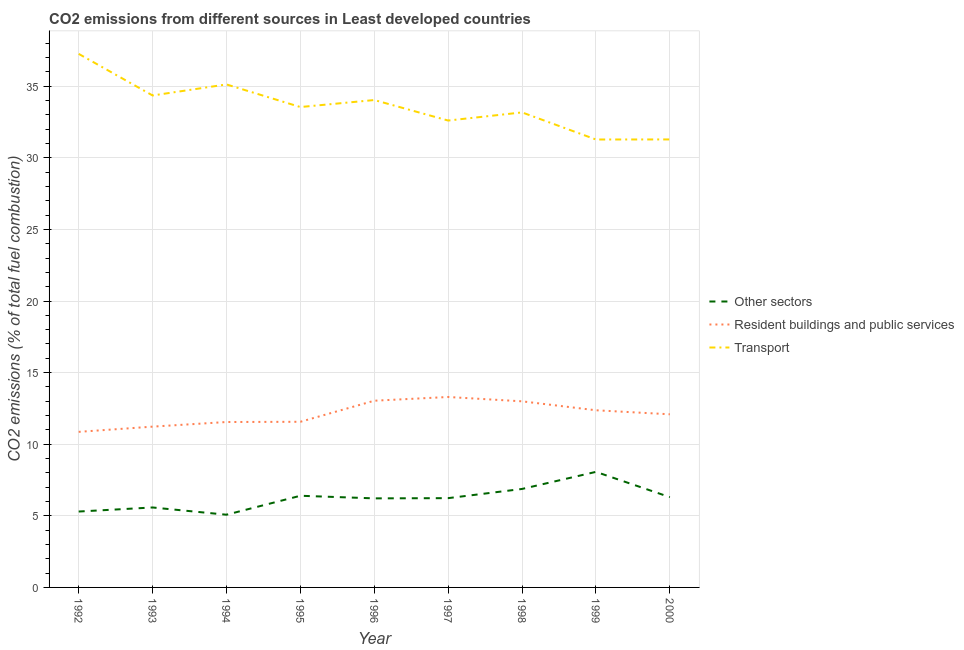How many different coloured lines are there?
Make the answer very short. 3. Does the line corresponding to percentage of co2 emissions from transport intersect with the line corresponding to percentage of co2 emissions from other sectors?
Offer a very short reply. No. What is the percentage of co2 emissions from other sectors in 1999?
Your answer should be compact. 8.07. Across all years, what is the maximum percentage of co2 emissions from resident buildings and public services?
Your answer should be compact. 13.3. Across all years, what is the minimum percentage of co2 emissions from resident buildings and public services?
Offer a terse response. 10.86. In which year was the percentage of co2 emissions from other sectors maximum?
Provide a succinct answer. 1999. What is the total percentage of co2 emissions from transport in the graph?
Provide a succinct answer. 302.67. What is the difference between the percentage of co2 emissions from transport in 1993 and that in 1996?
Your response must be concise. 0.32. What is the difference between the percentage of co2 emissions from transport in 1996 and the percentage of co2 emissions from resident buildings and public services in 1993?
Offer a terse response. 22.81. What is the average percentage of co2 emissions from other sectors per year?
Your response must be concise. 6.23. In the year 1999, what is the difference between the percentage of co2 emissions from transport and percentage of co2 emissions from other sectors?
Keep it short and to the point. 23.21. What is the ratio of the percentage of co2 emissions from resident buildings and public services in 1998 to that in 2000?
Offer a terse response. 1.07. What is the difference between the highest and the second highest percentage of co2 emissions from other sectors?
Give a very brief answer. 1.19. What is the difference between the highest and the lowest percentage of co2 emissions from resident buildings and public services?
Ensure brevity in your answer.  2.43. How many lines are there?
Give a very brief answer. 3. Are the values on the major ticks of Y-axis written in scientific E-notation?
Offer a very short reply. No. Where does the legend appear in the graph?
Provide a succinct answer. Center right. How many legend labels are there?
Offer a very short reply. 3. How are the legend labels stacked?
Provide a short and direct response. Vertical. What is the title of the graph?
Keep it short and to the point. CO2 emissions from different sources in Least developed countries. What is the label or title of the Y-axis?
Provide a succinct answer. CO2 emissions (% of total fuel combustion). What is the CO2 emissions (% of total fuel combustion) in Other sectors in 1992?
Ensure brevity in your answer.  5.3. What is the CO2 emissions (% of total fuel combustion) in Resident buildings and public services in 1992?
Your answer should be compact. 10.86. What is the CO2 emissions (% of total fuel combustion) in Transport in 1992?
Your response must be concise. 37.26. What is the CO2 emissions (% of total fuel combustion) of Other sectors in 1993?
Keep it short and to the point. 5.58. What is the CO2 emissions (% of total fuel combustion) in Resident buildings and public services in 1993?
Your response must be concise. 11.23. What is the CO2 emissions (% of total fuel combustion) in Transport in 1993?
Ensure brevity in your answer.  34.36. What is the CO2 emissions (% of total fuel combustion) in Other sectors in 1994?
Offer a terse response. 5.08. What is the CO2 emissions (% of total fuel combustion) of Resident buildings and public services in 1994?
Provide a short and direct response. 11.55. What is the CO2 emissions (% of total fuel combustion) in Transport in 1994?
Provide a short and direct response. 35.13. What is the CO2 emissions (% of total fuel combustion) of Other sectors in 1995?
Give a very brief answer. 6.4. What is the CO2 emissions (% of total fuel combustion) of Resident buildings and public services in 1995?
Offer a very short reply. 11.57. What is the CO2 emissions (% of total fuel combustion) in Transport in 1995?
Keep it short and to the point. 33.55. What is the CO2 emissions (% of total fuel combustion) of Other sectors in 1996?
Your response must be concise. 6.22. What is the CO2 emissions (% of total fuel combustion) of Resident buildings and public services in 1996?
Ensure brevity in your answer.  13.04. What is the CO2 emissions (% of total fuel combustion) in Transport in 1996?
Keep it short and to the point. 34.04. What is the CO2 emissions (% of total fuel combustion) of Other sectors in 1997?
Ensure brevity in your answer.  6.23. What is the CO2 emissions (% of total fuel combustion) in Resident buildings and public services in 1997?
Give a very brief answer. 13.3. What is the CO2 emissions (% of total fuel combustion) of Transport in 1997?
Provide a short and direct response. 32.6. What is the CO2 emissions (% of total fuel combustion) of Other sectors in 1998?
Give a very brief answer. 6.88. What is the CO2 emissions (% of total fuel combustion) in Resident buildings and public services in 1998?
Provide a short and direct response. 13. What is the CO2 emissions (% of total fuel combustion) of Transport in 1998?
Your answer should be very brief. 33.17. What is the CO2 emissions (% of total fuel combustion) in Other sectors in 1999?
Keep it short and to the point. 8.07. What is the CO2 emissions (% of total fuel combustion) in Resident buildings and public services in 1999?
Your answer should be compact. 12.37. What is the CO2 emissions (% of total fuel combustion) in Transport in 1999?
Give a very brief answer. 31.28. What is the CO2 emissions (% of total fuel combustion) in Other sectors in 2000?
Provide a succinct answer. 6.3. What is the CO2 emissions (% of total fuel combustion) of Resident buildings and public services in 2000?
Offer a very short reply. 12.09. What is the CO2 emissions (% of total fuel combustion) of Transport in 2000?
Offer a terse response. 31.29. Across all years, what is the maximum CO2 emissions (% of total fuel combustion) of Other sectors?
Make the answer very short. 8.07. Across all years, what is the maximum CO2 emissions (% of total fuel combustion) in Resident buildings and public services?
Keep it short and to the point. 13.3. Across all years, what is the maximum CO2 emissions (% of total fuel combustion) in Transport?
Give a very brief answer. 37.26. Across all years, what is the minimum CO2 emissions (% of total fuel combustion) of Other sectors?
Your response must be concise. 5.08. Across all years, what is the minimum CO2 emissions (% of total fuel combustion) in Resident buildings and public services?
Provide a succinct answer. 10.86. Across all years, what is the minimum CO2 emissions (% of total fuel combustion) of Transport?
Keep it short and to the point. 31.28. What is the total CO2 emissions (% of total fuel combustion) in Other sectors in the graph?
Offer a terse response. 56.07. What is the total CO2 emissions (% of total fuel combustion) of Resident buildings and public services in the graph?
Provide a succinct answer. 109.01. What is the total CO2 emissions (% of total fuel combustion) in Transport in the graph?
Ensure brevity in your answer.  302.67. What is the difference between the CO2 emissions (% of total fuel combustion) in Other sectors in 1992 and that in 1993?
Your answer should be very brief. -0.28. What is the difference between the CO2 emissions (% of total fuel combustion) of Resident buildings and public services in 1992 and that in 1993?
Ensure brevity in your answer.  -0.36. What is the difference between the CO2 emissions (% of total fuel combustion) in Transport in 1992 and that in 1993?
Your response must be concise. 2.91. What is the difference between the CO2 emissions (% of total fuel combustion) in Other sectors in 1992 and that in 1994?
Keep it short and to the point. 0.22. What is the difference between the CO2 emissions (% of total fuel combustion) of Resident buildings and public services in 1992 and that in 1994?
Give a very brief answer. -0.69. What is the difference between the CO2 emissions (% of total fuel combustion) of Transport in 1992 and that in 1994?
Offer a very short reply. 2.13. What is the difference between the CO2 emissions (% of total fuel combustion) in Other sectors in 1992 and that in 1995?
Offer a terse response. -1.1. What is the difference between the CO2 emissions (% of total fuel combustion) in Resident buildings and public services in 1992 and that in 1995?
Your answer should be compact. -0.7. What is the difference between the CO2 emissions (% of total fuel combustion) of Transport in 1992 and that in 1995?
Your response must be concise. 3.71. What is the difference between the CO2 emissions (% of total fuel combustion) of Other sectors in 1992 and that in 1996?
Your response must be concise. -0.92. What is the difference between the CO2 emissions (% of total fuel combustion) in Resident buildings and public services in 1992 and that in 1996?
Provide a succinct answer. -2.17. What is the difference between the CO2 emissions (% of total fuel combustion) of Transport in 1992 and that in 1996?
Give a very brief answer. 3.22. What is the difference between the CO2 emissions (% of total fuel combustion) in Other sectors in 1992 and that in 1997?
Keep it short and to the point. -0.94. What is the difference between the CO2 emissions (% of total fuel combustion) in Resident buildings and public services in 1992 and that in 1997?
Keep it short and to the point. -2.43. What is the difference between the CO2 emissions (% of total fuel combustion) in Transport in 1992 and that in 1997?
Your answer should be compact. 4.66. What is the difference between the CO2 emissions (% of total fuel combustion) in Other sectors in 1992 and that in 1998?
Provide a short and direct response. -1.58. What is the difference between the CO2 emissions (% of total fuel combustion) of Resident buildings and public services in 1992 and that in 1998?
Offer a terse response. -2.13. What is the difference between the CO2 emissions (% of total fuel combustion) in Transport in 1992 and that in 1998?
Offer a terse response. 4.09. What is the difference between the CO2 emissions (% of total fuel combustion) in Other sectors in 1992 and that in 1999?
Provide a short and direct response. -2.77. What is the difference between the CO2 emissions (% of total fuel combustion) in Resident buildings and public services in 1992 and that in 1999?
Provide a short and direct response. -1.51. What is the difference between the CO2 emissions (% of total fuel combustion) in Transport in 1992 and that in 1999?
Provide a short and direct response. 5.98. What is the difference between the CO2 emissions (% of total fuel combustion) of Other sectors in 1992 and that in 2000?
Give a very brief answer. -1. What is the difference between the CO2 emissions (% of total fuel combustion) in Resident buildings and public services in 1992 and that in 2000?
Your response must be concise. -1.23. What is the difference between the CO2 emissions (% of total fuel combustion) in Transport in 1992 and that in 2000?
Make the answer very short. 5.98. What is the difference between the CO2 emissions (% of total fuel combustion) in Other sectors in 1993 and that in 1994?
Your response must be concise. 0.51. What is the difference between the CO2 emissions (% of total fuel combustion) in Resident buildings and public services in 1993 and that in 1994?
Make the answer very short. -0.32. What is the difference between the CO2 emissions (% of total fuel combustion) of Transport in 1993 and that in 1994?
Provide a succinct answer. -0.77. What is the difference between the CO2 emissions (% of total fuel combustion) in Other sectors in 1993 and that in 1995?
Your answer should be compact. -0.82. What is the difference between the CO2 emissions (% of total fuel combustion) in Resident buildings and public services in 1993 and that in 1995?
Give a very brief answer. -0.34. What is the difference between the CO2 emissions (% of total fuel combustion) in Transport in 1993 and that in 1995?
Your response must be concise. 0.81. What is the difference between the CO2 emissions (% of total fuel combustion) of Other sectors in 1993 and that in 1996?
Offer a terse response. -0.64. What is the difference between the CO2 emissions (% of total fuel combustion) in Resident buildings and public services in 1993 and that in 1996?
Ensure brevity in your answer.  -1.81. What is the difference between the CO2 emissions (% of total fuel combustion) of Transport in 1993 and that in 1996?
Provide a short and direct response. 0.32. What is the difference between the CO2 emissions (% of total fuel combustion) in Other sectors in 1993 and that in 1997?
Offer a terse response. -0.65. What is the difference between the CO2 emissions (% of total fuel combustion) in Resident buildings and public services in 1993 and that in 1997?
Offer a very short reply. -2.07. What is the difference between the CO2 emissions (% of total fuel combustion) in Transport in 1993 and that in 1997?
Ensure brevity in your answer.  1.75. What is the difference between the CO2 emissions (% of total fuel combustion) in Other sectors in 1993 and that in 1998?
Offer a very short reply. -1.29. What is the difference between the CO2 emissions (% of total fuel combustion) in Resident buildings and public services in 1993 and that in 1998?
Give a very brief answer. -1.77. What is the difference between the CO2 emissions (% of total fuel combustion) of Transport in 1993 and that in 1998?
Provide a short and direct response. 1.18. What is the difference between the CO2 emissions (% of total fuel combustion) of Other sectors in 1993 and that in 1999?
Make the answer very short. -2.49. What is the difference between the CO2 emissions (% of total fuel combustion) of Resident buildings and public services in 1993 and that in 1999?
Offer a very short reply. -1.14. What is the difference between the CO2 emissions (% of total fuel combustion) in Transport in 1993 and that in 1999?
Offer a terse response. 3.08. What is the difference between the CO2 emissions (% of total fuel combustion) of Other sectors in 1993 and that in 2000?
Your response must be concise. -0.72. What is the difference between the CO2 emissions (% of total fuel combustion) in Resident buildings and public services in 1993 and that in 2000?
Keep it short and to the point. -0.86. What is the difference between the CO2 emissions (% of total fuel combustion) of Transport in 1993 and that in 2000?
Your response must be concise. 3.07. What is the difference between the CO2 emissions (% of total fuel combustion) of Other sectors in 1994 and that in 1995?
Offer a terse response. -1.32. What is the difference between the CO2 emissions (% of total fuel combustion) in Resident buildings and public services in 1994 and that in 1995?
Keep it short and to the point. -0.02. What is the difference between the CO2 emissions (% of total fuel combustion) of Transport in 1994 and that in 1995?
Your response must be concise. 1.58. What is the difference between the CO2 emissions (% of total fuel combustion) in Other sectors in 1994 and that in 1996?
Provide a short and direct response. -1.14. What is the difference between the CO2 emissions (% of total fuel combustion) of Resident buildings and public services in 1994 and that in 1996?
Provide a short and direct response. -1.49. What is the difference between the CO2 emissions (% of total fuel combustion) in Transport in 1994 and that in 1996?
Your answer should be compact. 1.09. What is the difference between the CO2 emissions (% of total fuel combustion) of Other sectors in 1994 and that in 1997?
Provide a short and direct response. -1.16. What is the difference between the CO2 emissions (% of total fuel combustion) of Resident buildings and public services in 1994 and that in 1997?
Provide a succinct answer. -1.75. What is the difference between the CO2 emissions (% of total fuel combustion) of Transport in 1994 and that in 1997?
Your response must be concise. 2.52. What is the difference between the CO2 emissions (% of total fuel combustion) of Other sectors in 1994 and that in 1998?
Make the answer very short. -1.8. What is the difference between the CO2 emissions (% of total fuel combustion) of Resident buildings and public services in 1994 and that in 1998?
Ensure brevity in your answer.  -1.44. What is the difference between the CO2 emissions (% of total fuel combustion) of Transport in 1994 and that in 1998?
Keep it short and to the point. 1.95. What is the difference between the CO2 emissions (% of total fuel combustion) of Other sectors in 1994 and that in 1999?
Your response must be concise. -2.99. What is the difference between the CO2 emissions (% of total fuel combustion) in Resident buildings and public services in 1994 and that in 1999?
Your response must be concise. -0.82. What is the difference between the CO2 emissions (% of total fuel combustion) in Transport in 1994 and that in 1999?
Keep it short and to the point. 3.85. What is the difference between the CO2 emissions (% of total fuel combustion) of Other sectors in 1994 and that in 2000?
Provide a short and direct response. -1.23. What is the difference between the CO2 emissions (% of total fuel combustion) of Resident buildings and public services in 1994 and that in 2000?
Ensure brevity in your answer.  -0.54. What is the difference between the CO2 emissions (% of total fuel combustion) in Transport in 1994 and that in 2000?
Offer a very short reply. 3.84. What is the difference between the CO2 emissions (% of total fuel combustion) in Other sectors in 1995 and that in 1996?
Give a very brief answer. 0.18. What is the difference between the CO2 emissions (% of total fuel combustion) of Resident buildings and public services in 1995 and that in 1996?
Give a very brief answer. -1.47. What is the difference between the CO2 emissions (% of total fuel combustion) of Transport in 1995 and that in 1996?
Provide a succinct answer. -0.49. What is the difference between the CO2 emissions (% of total fuel combustion) of Other sectors in 1995 and that in 1997?
Your answer should be very brief. 0.17. What is the difference between the CO2 emissions (% of total fuel combustion) in Resident buildings and public services in 1995 and that in 1997?
Your answer should be compact. -1.73. What is the difference between the CO2 emissions (% of total fuel combustion) of Transport in 1995 and that in 1997?
Offer a very short reply. 0.94. What is the difference between the CO2 emissions (% of total fuel combustion) of Other sectors in 1995 and that in 1998?
Give a very brief answer. -0.48. What is the difference between the CO2 emissions (% of total fuel combustion) in Resident buildings and public services in 1995 and that in 1998?
Your answer should be very brief. -1.43. What is the difference between the CO2 emissions (% of total fuel combustion) of Transport in 1995 and that in 1998?
Provide a succinct answer. 0.37. What is the difference between the CO2 emissions (% of total fuel combustion) of Other sectors in 1995 and that in 1999?
Make the answer very short. -1.67. What is the difference between the CO2 emissions (% of total fuel combustion) in Resident buildings and public services in 1995 and that in 1999?
Offer a terse response. -0.8. What is the difference between the CO2 emissions (% of total fuel combustion) in Transport in 1995 and that in 1999?
Ensure brevity in your answer.  2.27. What is the difference between the CO2 emissions (% of total fuel combustion) in Other sectors in 1995 and that in 2000?
Offer a very short reply. 0.1. What is the difference between the CO2 emissions (% of total fuel combustion) of Resident buildings and public services in 1995 and that in 2000?
Give a very brief answer. -0.52. What is the difference between the CO2 emissions (% of total fuel combustion) of Transport in 1995 and that in 2000?
Keep it short and to the point. 2.26. What is the difference between the CO2 emissions (% of total fuel combustion) of Other sectors in 1996 and that in 1997?
Ensure brevity in your answer.  -0.02. What is the difference between the CO2 emissions (% of total fuel combustion) of Resident buildings and public services in 1996 and that in 1997?
Your answer should be compact. -0.26. What is the difference between the CO2 emissions (% of total fuel combustion) in Transport in 1996 and that in 1997?
Ensure brevity in your answer.  1.43. What is the difference between the CO2 emissions (% of total fuel combustion) in Other sectors in 1996 and that in 1998?
Keep it short and to the point. -0.66. What is the difference between the CO2 emissions (% of total fuel combustion) in Resident buildings and public services in 1996 and that in 1998?
Provide a succinct answer. 0.04. What is the difference between the CO2 emissions (% of total fuel combustion) in Transport in 1996 and that in 1998?
Make the answer very short. 0.86. What is the difference between the CO2 emissions (% of total fuel combustion) of Other sectors in 1996 and that in 1999?
Make the answer very short. -1.85. What is the difference between the CO2 emissions (% of total fuel combustion) in Resident buildings and public services in 1996 and that in 1999?
Keep it short and to the point. 0.67. What is the difference between the CO2 emissions (% of total fuel combustion) in Transport in 1996 and that in 1999?
Your answer should be very brief. 2.76. What is the difference between the CO2 emissions (% of total fuel combustion) of Other sectors in 1996 and that in 2000?
Offer a terse response. -0.08. What is the difference between the CO2 emissions (% of total fuel combustion) of Resident buildings and public services in 1996 and that in 2000?
Your response must be concise. 0.95. What is the difference between the CO2 emissions (% of total fuel combustion) in Transport in 1996 and that in 2000?
Offer a very short reply. 2.75. What is the difference between the CO2 emissions (% of total fuel combustion) in Other sectors in 1997 and that in 1998?
Your answer should be compact. -0.64. What is the difference between the CO2 emissions (% of total fuel combustion) of Resident buildings and public services in 1997 and that in 1998?
Your answer should be very brief. 0.3. What is the difference between the CO2 emissions (% of total fuel combustion) in Transport in 1997 and that in 1998?
Give a very brief answer. -0.57. What is the difference between the CO2 emissions (% of total fuel combustion) in Other sectors in 1997 and that in 1999?
Your answer should be very brief. -1.84. What is the difference between the CO2 emissions (% of total fuel combustion) of Resident buildings and public services in 1997 and that in 1999?
Keep it short and to the point. 0.93. What is the difference between the CO2 emissions (% of total fuel combustion) of Transport in 1997 and that in 1999?
Offer a terse response. 1.32. What is the difference between the CO2 emissions (% of total fuel combustion) of Other sectors in 1997 and that in 2000?
Give a very brief answer. -0.07. What is the difference between the CO2 emissions (% of total fuel combustion) in Resident buildings and public services in 1997 and that in 2000?
Provide a short and direct response. 1.21. What is the difference between the CO2 emissions (% of total fuel combustion) of Transport in 1997 and that in 2000?
Ensure brevity in your answer.  1.32. What is the difference between the CO2 emissions (% of total fuel combustion) of Other sectors in 1998 and that in 1999?
Give a very brief answer. -1.19. What is the difference between the CO2 emissions (% of total fuel combustion) in Resident buildings and public services in 1998 and that in 1999?
Keep it short and to the point. 0.62. What is the difference between the CO2 emissions (% of total fuel combustion) in Transport in 1998 and that in 1999?
Keep it short and to the point. 1.89. What is the difference between the CO2 emissions (% of total fuel combustion) in Other sectors in 1998 and that in 2000?
Give a very brief answer. 0.57. What is the difference between the CO2 emissions (% of total fuel combustion) in Resident buildings and public services in 1998 and that in 2000?
Ensure brevity in your answer.  0.91. What is the difference between the CO2 emissions (% of total fuel combustion) of Transport in 1998 and that in 2000?
Your response must be concise. 1.89. What is the difference between the CO2 emissions (% of total fuel combustion) of Other sectors in 1999 and that in 2000?
Provide a short and direct response. 1.77. What is the difference between the CO2 emissions (% of total fuel combustion) in Resident buildings and public services in 1999 and that in 2000?
Ensure brevity in your answer.  0.28. What is the difference between the CO2 emissions (% of total fuel combustion) in Transport in 1999 and that in 2000?
Offer a very short reply. -0.01. What is the difference between the CO2 emissions (% of total fuel combustion) of Other sectors in 1992 and the CO2 emissions (% of total fuel combustion) of Resident buildings and public services in 1993?
Your response must be concise. -5.93. What is the difference between the CO2 emissions (% of total fuel combustion) of Other sectors in 1992 and the CO2 emissions (% of total fuel combustion) of Transport in 1993?
Ensure brevity in your answer.  -29.06. What is the difference between the CO2 emissions (% of total fuel combustion) in Resident buildings and public services in 1992 and the CO2 emissions (% of total fuel combustion) in Transport in 1993?
Your response must be concise. -23.49. What is the difference between the CO2 emissions (% of total fuel combustion) in Other sectors in 1992 and the CO2 emissions (% of total fuel combustion) in Resident buildings and public services in 1994?
Provide a succinct answer. -6.25. What is the difference between the CO2 emissions (% of total fuel combustion) of Other sectors in 1992 and the CO2 emissions (% of total fuel combustion) of Transport in 1994?
Offer a very short reply. -29.83. What is the difference between the CO2 emissions (% of total fuel combustion) of Resident buildings and public services in 1992 and the CO2 emissions (% of total fuel combustion) of Transport in 1994?
Provide a succinct answer. -24.26. What is the difference between the CO2 emissions (% of total fuel combustion) in Other sectors in 1992 and the CO2 emissions (% of total fuel combustion) in Resident buildings and public services in 1995?
Keep it short and to the point. -6.27. What is the difference between the CO2 emissions (% of total fuel combustion) in Other sectors in 1992 and the CO2 emissions (% of total fuel combustion) in Transport in 1995?
Offer a very short reply. -28.25. What is the difference between the CO2 emissions (% of total fuel combustion) in Resident buildings and public services in 1992 and the CO2 emissions (% of total fuel combustion) in Transport in 1995?
Keep it short and to the point. -22.68. What is the difference between the CO2 emissions (% of total fuel combustion) in Other sectors in 1992 and the CO2 emissions (% of total fuel combustion) in Resident buildings and public services in 1996?
Ensure brevity in your answer.  -7.74. What is the difference between the CO2 emissions (% of total fuel combustion) in Other sectors in 1992 and the CO2 emissions (% of total fuel combustion) in Transport in 1996?
Offer a terse response. -28.74. What is the difference between the CO2 emissions (% of total fuel combustion) of Resident buildings and public services in 1992 and the CO2 emissions (% of total fuel combustion) of Transport in 1996?
Keep it short and to the point. -23.17. What is the difference between the CO2 emissions (% of total fuel combustion) in Other sectors in 1992 and the CO2 emissions (% of total fuel combustion) in Resident buildings and public services in 1997?
Provide a short and direct response. -8. What is the difference between the CO2 emissions (% of total fuel combustion) of Other sectors in 1992 and the CO2 emissions (% of total fuel combustion) of Transport in 1997?
Offer a very short reply. -27.3. What is the difference between the CO2 emissions (% of total fuel combustion) in Resident buildings and public services in 1992 and the CO2 emissions (% of total fuel combustion) in Transport in 1997?
Keep it short and to the point. -21.74. What is the difference between the CO2 emissions (% of total fuel combustion) of Other sectors in 1992 and the CO2 emissions (% of total fuel combustion) of Resident buildings and public services in 1998?
Make the answer very short. -7.7. What is the difference between the CO2 emissions (% of total fuel combustion) of Other sectors in 1992 and the CO2 emissions (% of total fuel combustion) of Transport in 1998?
Provide a succinct answer. -27.87. What is the difference between the CO2 emissions (% of total fuel combustion) in Resident buildings and public services in 1992 and the CO2 emissions (% of total fuel combustion) in Transport in 1998?
Your answer should be compact. -22.31. What is the difference between the CO2 emissions (% of total fuel combustion) in Other sectors in 1992 and the CO2 emissions (% of total fuel combustion) in Resident buildings and public services in 1999?
Your response must be concise. -7.07. What is the difference between the CO2 emissions (% of total fuel combustion) in Other sectors in 1992 and the CO2 emissions (% of total fuel combustion) in Transport in 1999?
Ensure brevity in your answer.  -25.98. What is the difference between the CO2 emissions (% of total fuel combustion) of Resident buildings and public services in 1992 and the CO2 emissions (% of total fuel combustion) of Transport in 1999?
Your response must be concise. -20.42. What is the difference between the CO2 emissions (% of total fuel combustion) in Other sectors in 1992 and the CO2 emissions (% of total fuel combustion) in Resident buildings and public services in 2000?
Your answer should be very brief. -6.79. What is the difference between the CO2 emissions (% of total fuel combustion) of Other sectors in 1992 and the CO2 emissions (% of total fuel combustion) of Transport in 2000?
Your response must be concise. -25.99. What is the difference between the CO2 emissions (% of total fuel combustion) in Resident buildings and public services in 1992 and the CO2 emissions (% of total fuel combustion) in Transport in 2000?
Give a very brief answer. -20.42. What is the difference between the CO2 emissions (% of total fuel combustion) in Other sectors in 1993 and the CO2 emissions (% of total fuel combustion) in Resident buildings and public services in 1994?
Your answer should be compact. -5.97. What is the difference between the CO2 emissions (% of total fuel combustion) in Other sectors in 1993 and the CO2 emissions (% of total fuel combustion) in Transport in 1994?
Keep it short and to the point. -29.54. What is the difference between the CO2 emissions (% of total fuel combustion) in Resident buildings and public services in 1993 and the CO2 emissions (% of total fuel combustion) in Transport in 1994?
Your response must be concise. -23.9. What is the difference between the CO2 emissions (% of total fuel combustion) in Other sectors in 1993 and the CO2 emissions (% of total fuel combustion) in Resident buildings and public services in 1995?
Your answer should be very brief. -5.98. What is the difference between the CO2 emissions (% of total fuel combustion) of Other sectors in 1993 and the CO2 emissions (% of total fuel combustion) of Transport in 1995?
Ensure brevity in your answer.  -27.96. What is the difference between the CO2 emissions (% of total fuel combustion) in Resident buildings and public services in 1993 and the CO2 emissions (% of total fuel combustion) in Transport in 1995?
Give a very brief answer. -22.32. What is the difference between the CO2 emissions (% of total fuel combustion) of Other sectors in 1993 and the CO2 emissions (% of total fuel combustion) of Resident buildings and public services in 1996?
Keep it short and to the point. -7.46. What is the difference between the CO2 emissions (% of total fuel combustion) of Other sectors in 1993 and the CO2 emissions (% of total fuel combustion) of Transport in 1996?
Provide a short and direct response. -28.45. What is the difference between the CO2 emissions (% of total fuel combustion) of Resident buildings and public services in 1993 and the CO2 emissions (% of total fuel combustion) of Transport in 1996?
Offer a terse response. -22.81. What is the difference between the CO2 emissions (% of total fuel combustion) in Other sectors in 1993 and the CO2 emissions (% of total fuel combustion) in Resident buildings and public services in 1997?
Give a very brief answer. -7.72. What is the difference between the CO2 emissions (% of total fuel combustion) of Other sectors in 1993 and the CO2 emissions (% of total fuel combustion) of Transport in 1997?
Offer a terse response. -27.02. What is the difference between the CO2 emissions (% of total fuel combustion) in Resident buildings and public services in 1993 and the CO2 emissions (% of total fuel combustion) in Transport in 1997?
Make the answer very short. -21.38. What is the difference between the CO2 emissions (% of total fuel combustion) in Other sectors in 1993 and the CO2 emissions (% of total fuel combustion) in Resident buildings and public services in 1998?
Keep it short and to the point. -7.41. What is the difference between the CO2 emissions (% of total fuel combustion) of Other sectors in 1993 and the CO2 emissions (% of total fuel combustion) of Transport in 1998?
Provide a succinct answer. -27.59. What is the difference between the CO2 emissions (% of total fuel combustion) in Resident buildings and public services in 1993 and the CO2 emissions (% of total fuel combustion) in Transport in 1998?
Provide a short and direct response. -21.94. What is the difference between the CO2 emissions (% of total fuel combustion) of Other sectors in 1993 and the CO2 emissions (% of total fuel combustion) of Resident buildings and public services in 1999?
Keep it short and to the point. -6.79. What is the difference between the CO2 emissions (% of total fuel combustion) of Other sectors in 1993 and the CO2 emissions (% of total fuel combustion) of Transport in 1999?
Offer a terse response. -25.7. What is the difference between the CO2 emissions (% of total fuel combustion) in Resident buildings and public services in 1993 and the CO2 emissions (% of total fuel combustion) in Transport in 1999?
Your response must be concise. -20.05. What is the difference between the CO2 emissions (% of total fuel combustion) of Other sectors in 1993 and the CO2 emissions (% of total fuel combustion) of Resident buildings and public services in 2000?
Your response must be concise. -6.51. What is the difference between the CO2 emissions (% of total fuel combustion) of Other sectors in 1993 and the CO2 emissions (% of total fuel combustion) of Transport in 2000?
Your answer should be compact. -25.7. What is the difference between the CO2 emissions (% of total fuel combustion) of Resident buildings and public services in 1993 and the CO2 emissions (% of total fuel combustion) of Transport in 2000?
Offer a terse response. -20.06. What is the difference between the CO2 emissions (% of total fuel combustion) in Other sectors in 1994 and the CO2 emissions (% of total fuel combustion) in Resident buildings and public services in 1995?
Keep it short and to the point. -6.49. What is the difference between the CO2 emissions (% of total fuel combustion) of Other sectors in 1994 and the CO2 emissions (% of total fuel combustion) of Transport in 1995?
Your answer should be very brief. -28.47. What is the difference between the CO2 emissions (% of total fuel combustion) in Resident buildings and public services in 1994 and the CO2 emissions (% of total fuel combustion) in Transport in 1995?
Provide a succinct answer. -22. What is the difference between the CO2 emissions (% of total fuel combustion) of Other sectors in 1994 and the CO2 emissions (% of total fuel combustion) of Resident buildings and public services in 1996?
Your response must be concise. -7.96. What is the difference between the CO2 emissions (% of total fuel combustion) of Other sectors in 1994 and the CO2 emissions (% of total fuel combustion) of Transport in 1996?
Provide a short and direct response. -28.96. What is the difference between the CO2 emissions (% of total fuel combustion) of Resident buildings and public services in 1994 and the CO2 emissions (% of total fuel combustion) of Transport in 1996?
Offer a terse response. -22.48. What is the difference between the CO2 emissions (% of total fuel combustion) of Other sectors in 1994 and the CO2 emissions (% of total fuel combustion) of Resident buildings and public services in 1997?
Offer a terse response. -8.22. What is the difference between the CO2 emissions (% of total fuel combustion) in Other sectors in 1994 and the CO2 emissions (% of total fuel combustion) in Transport in 1997?
Your response must be concise. -27.53. What is the difference between the CO2 emissions (% of total fuel combustion) in Resident buildings and public services in 1994 and the CO2 emissions (% of total fuel combustion) in Transport in 1997?
Make the answer very short. -21.05. What is the difference between the CO2 emissions (% of total fuel combustion) in Other sectors in 1994 and the CO2 emissions (% of total fuel combustion) in Resident buildings and public services in 1998?
Keep it short and to the point. -7.92. What is the difference between the CO2 emissions (% of total fuel combustion) of Other sectors in 1994 and the CO2 emissions (% of total fuel combustion) of Transport in 1998?
Keep it short and to the point. -28.1. What is the difference between the CO2 emissions (% of total fuel combustion) of Resident buildings and public services in 1994 and the CO2 emissions (% of total fuel combustion) of Transport in 1998?
Your response must be concise. -21.62. What is the difference between the CO2 emissions (% of total fuel combustion) in Other sectors in 1994 and the CO2 emissions (% of total fuel combustion) in Resident buildings and public services in 1999?
Your answer should be very brief. -7.29. What is the difference between the CO2 emissions (% of total fuel combustion) of Other sectors in 1994 and the CO2 emissions (% of total fuel combustion) of Transport in 1999?
Your answer should be compact. -26.2. What is the difference between the CO2 emissions (% of total fuel combustion) in Resident buildings and public services in 1994 and the CO2 emissions (% of total fuel combustion) in Transport in 1999?
Give a very brief answer. -19.73. What is the difference between the CO2 emissions (% of total fuel combustion) of Other sectors in 1994 and the CO2 emissions (% of total fuel combustion) of Resident buildings and public services in 2000?
Make the answer very short. -7.01. What is the difference between the CO2 emissions (% of total fuel combustion) in Other sectors in 1994 and the CO2 emissions (% of total fuel combustion) in Transport in 2000?
Your answer should be very brief. -26.21. What is the difference between the CO2 emissions (% of total fuel combustion) of Resident buildings and public services in 1994 and the CO2 emissions (% of total fuel combustion) of Transport in 2000?
Your response must be concise. -19.73. What is the difference between the CO2 emissions (% of total fuel combustion) in Other sectors in 1995 and the CO2 emissions (% of total fuel combustion) in Resident buildings and public services in 1996?
Make the answer very short. -6.64. What is the difference between the CO2 emissions (% of total fuel combustion) of Other sectors in 1995 and the CO2 emissions (% of total fuel combustion) of Transport in 1996?
Make the answer very short. -27.63. What is the difference between the CO2 emissions (% of total fuel combustion) in Resident buildings and public services in 1995 and the CO2 emissions (% of total fuel combustion) in Transport in 1996?
Your response must be concise. -22.47. What is the difference between the CO2 emissions (% of total fuel combustion) in Other sectors in 1995 and the CO2 emissions (% of total fuel combustion) in Resident buildings and public services in 1997?
Keep it short and to the point. -6.9. What is the difference between the CO2 emissions (% of total fuel combustion) of Other sectors in 1995 and the CO2 emissions (% of total fuel combustion) of Transport in 1997?
Offer a very short reply. -26.2. What is the difference between the CO2 emissions (% of total fuel combustion) in Resident buildings and public services in 1995 and the CO2 emissions (% of total fuel combustion) in Transport in 1997?
Provide a succinct answer. -21.04. What is the difference between the CO2 emissions (% of total fuel combustion) in Other sectors in 1995 and the CO2 emissions (% of total fuel combustion) in Resident buildings and public services in 1998?
Provide a short and direct response. -6.59. What is the difference between the CO2 emissions (% of total fuel combustion) of Other sectors in 1995 and the CO2 emissions (% of total fuel combustion) of Transport in 1998?
Your response must be concise. -26.77. What is the difference between the CO2 emissions (% of total fuel combustion) in Resident buildings and public services in 1995 and the CO2 emissions (% of total fuel combustion) in Transport in 1998?
Ensure brevity in your answer.  -21.61. What is the difference between the CO2 emissions (% of total fuel combustion) in Other sectors in 1995 and the CO2 emissions (% of total fuel combustion) in Resident buildings and public services in 1999?
Offer a very short reply. -5.97. What is the difference between the CO2 emissions (% of total fuel combustion) in Other sectors in 1995 and the CO2 emissions (% of total fuel combustion) in Transport in 1999?
Your answer should be very brief. -24.88. What is the difference between the CO2 emissions (% of total fuel combustion) in Resident buildings and public services in 1995 and the CO2 emissions (% of total fuel combustion) in Transport in 1999?
Provide a succinct answer. -19.71. What is the difference between the CO2 emissions (% of total fuel combustion) of Other sectors in 1995 and the CO2 emissions (% of total fuel combustion) of Resident buildings and public services in 2000?
Keep it short and to the point. -5.69. What is the difference between the CO2 emissions (% of total fuel combustion) of Other sectors in 1995 and the CO2 emissions (% of total fuel combustion) of Transport in 2000?
Your answer should be compact. -24.88. What is the difference between the CO2 emissions (% of total fuel combustion) in Resident buildings and public services in 1995 and the CO2 emissions (% of total fuel combustion) in Transport in 2000?
Ensure brevity in your answer.  -19.72. What is the difference between the CO2 emissions (% of total fuel combustion) of Other sectors in 1996 and the CO2 emissions (% of total fuel combustion) of Resident buildings and public services in 1997?
Offer a very short reply. -7.08. What is the difference between the CO2 emissions (% of total fuel combustion) of Other sectors in 1996 and the CO2 emissions (% of total fuel combustion) of Transport in 1997?
Make the answer very short. -26.38. What is the difference between the CO2 emissions (% of total fuel combustion) of Resident buildings and public services in 1996 and the CO2 emissions (% of total fuel combustion) of Transport in 1997?
Your response must be concise. -19.57. What is the difference between the CO2 emissions (% of total fuel combustion) in Other sectors in 1996 and the CO2 emissions (% of total fuel combustion) in Resident buildings and public services in 1998?
Provide a succinct answer. -6.78. What is the difference between the CO2 emissions (% of total fuel combustion) in Other sectors in 1996 and the CO2 emissions (% of total fuel combustion) in Transport in 1998?
Offer a terse response. -26.95. What is the difference between the CO2 emissions (% of total fuel combustion) of Resident buildings and public services in 1996 and the CO2 emissions (% of total fuel combustion) of Transport in 1998?
Give a very brief answer. -20.13. What is the difference between the CO2 emissions (% of total fuel combustion) in Other sectors in 1996 and the CO2 emissions (% of total fuel combustion) in Resident buildings and public services in 1999?
Ensure brevity in your answer.  -6.15. What is the difference between the CO2 emissions (% of total fuel combustion) in Other sectors in 1996 and the CO2 emissions (% of total fuel combustion) in Transport in 1999?
Keep it short and to the point. -25.06. What is the difference between the CO2 emissions (% of total fuel combustion) of Resident buildings and public services in 1996 and the CO2 emissions (% of total fuel combustion) of Transport in 1999?
Your answer should be very brief. -18.24. What is the difference between the CO2 emissions (% of total fuel combustion) of Other sectors in 1996 and the CO2 emissions (% of total fuel combustion) of Resident buildings and public services in 2000?
Your answer should be compact. -5.87. What is the difference between the CO2 emissions (% of total fuel combustion) of Other sectors in 1996 and the CO2 emissions (% of total fuel combustion) of Transport in 2000?
Offer a very short reply. -25.07. What is the difference between the CO2 emissions (% of total fuel combustion) in Resident buildings and public services in 1996 and the CO2 emissions (% of total fuel combustion) in Transport in 2000?
Your answer should be compact. -18.25. What is the difference between the CO2 emissions (% of total fuel combustion) of Other sectors in 1997 and the CO2 emissions (% of total fuel combustion) of Resident buildings and public services in 1998?
Keep it short and to the point. -6.76. What is the difference between the CO2 emissions (% of total fuel combustion) of Other sectors in 1997 and the CO2 emissions (% of total fuel combustion) of Transport in 1998?
Offer a terse response. -26.94. What is the difference between the CO2 emissions (% of total fuel combustion) of Resident buildings and public services in 1997 and the CO2 emissions (% of total fuel combustion) of Transport in 1998?
Your answer should be very brief. -19.87. What is the difference between the CO2 emissions (% of total fuel combustion) of Other sectors in 1997 and the CO2 emissions (% of total fuel combustion) of Resident buildings and public services in 1999?
Your response must be concise. -6.14. What is the difference between the CO2 emissions (% of total fuel combustion) of Other sectors in 1997 and the CO2 emissions (% of total fuel combustion) of Transport in 1999?
Make the answer very short. -25.05. What is the difference between the CO2 emissions (% of total fuel combustion) in Resident buildings and public services in 1997 and the CO2 emissions (% of total fuel combustion) in Transport in 1999?
Your answer should be very brief. -17.98. What is the difference between the CO2 emissions (% of total fuel combustion) in Other sectors in 1997 and the CO2 emissions (% of total fuel combustion) in Resident buildings and public services in 2000?
Keep it short and to the point. -5.86. What is the difference between the CO2 emissions (% of total fuel combustion) of Other sectors in 1997 and the CO2 emissions (% of total fuel combustion) of Transport in 2000?
Offer a very short reply. -25.05. What is the difference between the CO2 emissions (% of total fuel combustion) in Resident buildings and public services in 1997 and the CO2 emissions (% of total fuel combustion) in Transport in 2000?
Offer a very short reply. -17.99. What is the difference between the CO2 emissions (% of total fuel combustion) in Other sectors in 1998 and the CO2 emissions (% of total fuel combustion) in Resident buildings and public services in 1999?
Ensure brevity in your answer.  -5.49. What is the difference between the CO2 emissions (% of total fuel combustion) in Other sectors in 1998 and the CO2 emissions (% of total fuel combustion) in Transport in 1999?
Give a very brief answer. -24.4. What is the difference between the CO2 emissions (% of total fuel combustion) of Resident buildings and public services in 1998 and the CO2 emissions (% of total fuel combustion) of Transport in 1999?
Offer a terse response. -18.28. What is the difference between the CO2 emissions (% of total fuel combustion) of Other sectors in 1998 and the CO2 emissions (% of total fuel combustion) of Resident buildings and public services in 2000?
Make the answer very short. -5.21. What is the difference between the CO2 emissions (% of total fuel combustion) in Other sectors in 1998 and the CO2 emissions (% of total fuel combustion) in Transport in 2000?
Keep it short and to the point. -24.41. What is the difference between the CO2 emissions (% of total fuel combustion) in Resident buildings and public services in 1998 and the CO2 emissions (% of total fuel combustion) in Transport in 2000?
Your response must be concise. -18.29. What is the difference between the CO2 emissions (% of total fuel combustion) of Other sectors in 1999 and the CO2 emissions (% of total fuel combustion) of Resident buildings and public services in 2000?
Ensure brevity in your answer.  -4.02. What is the difference between the CO2 emissions (% of total fuel combustion) of Other sectors in 1999 and the CO2 emissions (% of total fuel combustion) of Transport in 2000?
Offer a terse response. -23.22. What is the difference between the CO2 emissions (% of total fuel combustion) of Resident buildings and public services in 1999 and the CO2 emissions (% of total fuel combustion) of Transport in 2000?
Your response must be concise. -18.91. What is the average CO2 emissions (% of total fuel combustion) of Other sectors per year?
Keep it short and to the point. 6.23. What is the average CO2 emissions (% of total fuel combustion) of Resident buildings and public services per year?
Offer a very short reply. 12.11. What is the average CO2 emissions (% of total fuel combustion) in Transport per year?
Your answer should be very brief. 33.63. In the year 1992, what is the difference between the CO2 emissions (% of total fuel combustion) in Other sectors and CO2 emissions (% of total fuel combustion) in Resident buildings and public services?
Your answer should be very brief. -5.56. In the year 1992, what is the difference between the CO2 emissions (% of total fuel combustion) in Other sectors and CO2 emissions (% of total fuel combustion) in Transport?
Your answer should be very brief. -31.96. In the year 1992, what is the difference between the CO2 emissions (% of total fuel combustion) in Resident buildings and public services and CO2 emissions (% of total fuel combustion) in Transport?
Ensure brevity in your answer.  -26.4. In the year 1993, what is the difference between the CO2 emissions (% of total fuel combustion) of Other sectors and CO2 emissions (% of total fuel combustion) of Resident buildings and public services?
Your answer should be compact. -5.64. In the year 1993, what is the difference between the CO2 emissions (% of total fuel combustion) in Other sectors and CO2 emissions (% of total fuel combustion) in Transport?
Ensure brevity in your answer.  -28.77. In the year 1993, what is the difference between the CO2 emissions (% of total fuel combustion) of Resident buildings and public services and CO2 emissions (% of total fuel combustion) of Transport?
Offer a terse response. -23.13. In the year 1994, what is the difference between the CO2 emissions (% of total fuel combustion) in Other sectors and CO2 emissions (% of total fuel combustion) in Resident buildings and public services?
Provide a short and direct response. -6.47. In the year 1994, what is the difference between the CO2 emissions (% of total fuel combustion) in Other sectors and CO2 emissions (% of total fuel combustion) in Transport?
Ensure brevity in your answer.  -30.05. In the year 1994, what is the difference between the CO2 emissions (% of total fuel combustion) of Resident buildings and public services and CO2 emissions (% of total fuel combustion) of Transport?
Your response must be concise. -23.57. In the year 1995, what is the difference between the CO2 emissions (% of total fuel combustion) of Other sectors and CO2 emissions (% of total fuel combustion) of Resident buildings and public services?
Give a very brief answer. -5.17. In the year 1995, what is the difference between the CO2 emissions (% of total fuel combustion) in Other sectors and CO2 emissions (% of total fuel combustion) in Transport?
Your answer should be compact. -27.15. In the year 1995, what is the difference between the CO2 emissions (% of total fuel combustion) of Resident buildings and public services and CO2 emissions (% of total fuel combustion) of Transport?
Offer a terse response. -21.98. In the year 1996, what is the difference between the CO2 emissions (% of total fuel combustion) of Other sectors and CO2 emissions (% of total fuel combustion) of Resident buildings and public services?
Your answer should be very brief. -6.82. In the year 1996, what is the difference between the CO2 emissions (% of total fuel combustion) of Other sectors and CO2 emissions (% of total fuel combustion) of Transport?
Give a very brief answer. -27.82. In the year 1996, what is the difference between the CO2 emissions (% of total fuel combustion) of Resident buildings and public services and CO2 emissions (% of total fuel combustion) of Transport?
Ensure brevity in your answer.  -21. In the year 1997, what is the difference between the CO2 emissions (% of total fuel combustion) of Other sectors and CO2 emissions (% of total fuel combustion) of Resident buildings and public services?
Your response must be concise. -7.06. In the year 1997, what is the difference between the CO2 emissions (% of total fuel combustion) of Other sectors and CO2 emissions (% of total fuel combustion) of Transport?
Your answer should be very brief. -26.37. In the year 1997, what is the difference between the CO2 emissions (% of total fuel combustion) in Resident buildings and public services and CO2 emissions (% of total fuel combustion) in Transport?
Ensure brevity in your answer.  -19.3. In the year 1998, what is the difference between the CO2 emissions (% of total fuel combustion) in Other sectors and CO2 emissions (% of total fuel combustion) in Resident buildings and public services?
Offer a very short reply. -6.12. In the year 1998, what is the difference between the CO2 emissions (% of total fuel combustion) in Other sectors and CO2 emissions (% of total fuel combustion) in Transport?
Provide a succinct answer. -26.3. In the year 1998, what is the difference between the CO2 emissions (% of total fuel combustion) of Resident buildings and public services and CO2 emissions (% of total fuel combustion) of Transport?
Make the answer very short. -20.18. In the year 1999, what is the difference between the CO2 emissions (% of total fuel combustion) in Other sectors and CO2 emissions (% of total fuel combustion) in Resident buildings and public services?
Offer a very short reply. -4.3. In the year 1999, what is the difference between the CO2 emissions (% of total fuel combustion) in Other sectors and CO2 emissions (% of total fuel combustion) in Transport?
Offer a terse response. -23.21. In the year 1999, what is the difference between the CO2 emissions (% of total fuel combustion) of Resident buildings and public services and CO2 emissions (% of total fuel combustion) of Transport?
Provide a succinct answer. -18.91. In the year 2000, what is the difference between the CO2 emissions (% of total fuel combustion) of Other sectors and CO2 emissions (% of total fuel combustion) of Resident buildings and public services?
Provide a succinct answer. -5.79. In the year 2000, what is the difference between the CO2 emissions (% of total fuel combustion) of Other sectors and CO2 emissions (% of total fuel combustion) of Transport?
Provide a succinct answer. -24.98. In the year 2000, what is the difference between the CO2 emissions (% of total fuel combustion) of Resident buildings and public services and CO2 emissions (% of total fuel combustion) of Transport?
Keep it short and to the point. -19.19. What is the ratio of the CO2 emissions (% of total fuel combustion) of Other sectors in 1992 to that in 1993?
Your answer should be compact. 0.95. What is the ratio of the CO2 emissions (% of total fuel combustion) in Resident buildings and public services in 1992 to that in 1993?
Provide a short and direct response. 0.97. What is the ratio of the CO2 emissions (% of total fuel combustion) of Transport in 1992 to that in 1993?
Offer a terse response. 1.08. What is the ratio of the CO2 emissions (% of total fuel combustion) in Other sectors in 1992 to that in 1994?
Make the answer very short. 1.04. What is the ratio of the CO2 emissions (% of total fuel combustion) of Resident buildings and public services in 1992 to that in 1994?
Your response must be concise. 0.94. What is the ratio of the CO2 emissions (% of total fuel combustion) of Transport in 1992 to that in 1994?
Give a very brief answer. 1.06. What is the ratio of the CO2 emissions (% of total fuel combustion) in Other sectors in 1992 to that in 1995?
Offer a very short reply. 0.83. What is the ratio of the CO2 emissions (% of total fuel combustion) in Resident buildings and public services in 1992 to that in 1995?
Provide a succinct answer. 0.94. What is the ratio of the CO2 emissions (% of total fuel combustion) of Transport in 1992 to that in 1995?
Offer a terse response. 1.11. What is the ratio of the CO2 emissions (% of total fuel combustion) in Other sectors in 1992 to that in 1996?
Keep it short and to the point. 0.85. What is the ratio of the CO2 emissions (% of total fuel combustion) of Resident buildings and public services in 1992 to that in 1996?
Your answer should be compact. 0.83. What is the ratio of the CO2 emissions (% of total fuel combustion) of Transport in 1992 to that in 1996?
Your answer should be very brief. 1.09. What is the ratio of the CO2 emissions (% of total fuel combustion) in Resident buildings and public services in 1992 to that in 1997?
Your response must be concise. 0.82. What is the ratio of the CO2 emissions (% of total fuel combustion) of Transport in 1992 to that in 1997?
Make the answer very short. 1.14. What is the ratio of the CO2 emissions (% of total fuel combustion) in Other sectors in 1992 to that in 1998?
Your answer should be very brief. 0.77. What is the ratio of the CO2 emissions (% of total fuel combustion) of Resident buildings and public services in 1992 to that in 1998?
Give a very brief answer. 0.84. What is the ratio of the CO2 emissions (% of total fuel combustion) in Transport in 1992 to that in 1998?
Your response must be concise. 1.12. What is the ratio of the CO2 emissions (% of total fuel combustion) in Other sectors in 1992 to that in 1999?
Your answer should be compact. 0.66. What is the ratio of the CO2 emissions (% of total fuel combustion) in Resident buildings and public services in 1992 to that in 1999?
Provide a short and direct response. 0.88. What is the ratio of the CO2 emissions (% of total fuel combustion) of Transport in 1992 to that in 1999?
Offer a terse response. 1.19. What is the ratio of the CO2 emissions (% of total fuel combustion) of Other sectors in 1992 to that in 2000?
Give a very brief answer. 0.84. What is the ratio of the CO2 emissions (% of total fuel combustion) in Resident buildings and public services in 1992 to that in 2000?
Give a very brief answer. 0.9. What is the ratio of the CO2 emissions (% of total fuel combustion) of Transport in 1992 to that in 2000?
Your answer should be very brief. 1.19. What is the ratio of the CO2 emissions (% of total fuel combustion) in Other sectors in 1993 to that in 1994?
Offer a very short reply. 1.1. What is the ratio of the CO2 emissions (% of total fuel combustion) of Other sectors in 1993 to that in 1995?
Ensure brevity in your answer.  0.87. What is the ratio of the CO2 emissions (% of total fuel combustion) in Resident buildings and public services in 1993 to that in 1995?
Offer a terse response. 0.97. What is the ratio of the CO2 emissions (% of total fuel combustion) in Transport in 1993 to that in 1995?
Offer a terse response. 1.02. What is the ratio of the CO2 emissions (% of total fuel combustion) of Other sectors in 1993 to that in 1996?
Offer a terse response. 0.9. What is the ratio of the CO2 emissions (% of total fuel combustion) of Resident buildings and public services in 1993 to that in 1996?
Your answer should be very brief. 0.86. What is the ratio of the CO2 emissions (% of total fuel combustion) of Transport in 1993 to that in 1996?
Offer a terse response. 1.01. What is the ratio of the CO2 emissions (% of total fuel combustion) in Other sectors in 1993 to that in 1997?
Provide a short and direct response. 0.9. What is the ratio of the CO2 emissions (% of total fuel combustion) in Resident buildings and public services in 1993 to that in 1997?
Offer a very short reply. 0.84. What is the ratio of the CO2 emissions (% of total fuel combustion) of Transport in 1993 to that in 1997?
Provide a short and direct response. 1.05. What is the ratio of the CO2 emissions (% of total fuel combustion) of Other sectors in 1993 to that in 1998?
Offer a terse response. 0.81. What is the ratio of the CO2 emissions (% of total fuel combustion) of Resident buildings and public services in 1993 to that in 1998?
Provide a short and direct response. 0.86. What is the ratio of the CO2 emissions (% of total fuel combustion) in Transport in 1993 to that in 1998?
Give a very brief answer. 1.04. What is the ratio of the CO2 emissions (% of total fuel combustion) in Other sectors in 1993 to that in 1999?
Keep it short and to the point. 0.69. What is the ratio of the CO2 emissions (% of total fuel combustion) in Resident buildings and public services in 1993 to that in 1999?
Ensure brevity in your answer.  0.91. What is the ratio of the CO2 emissions (% of total fuel combustion) of Transport in 1993 to that in 1999?
Your answer should be compact. 1.1. What is the ratio of the CO2 emissions (% of total fuel combustion) in Other sectors in 1993 to that in 2000?
Provide a succinct answer. 0.89. What is the ratio of the CO2 emissions (% of total fuel combustion) of Resident buildings and public services in 1993 to that in 2000?
Offer a very short reply. 0.93. What is the ratio of the CO2 emissions (% of total fuel combustion) in Transport in 1993 to that in 2000?
Provide a succinct answer. 1.1. What is the ratio of the CO2 emissions (% of total fuel combustion) in Other sectors in 1994 to that in 1995?
Provide a short and direct response. 0.79. What is the ratio of the CO2 emissions (% of total fuel combustion) in Resident buildings and public services in 1994 to that in 1995?
Keep it short and to the point. 1. What is the ratio of the CO2 emissions (% of total fuel combustion) of Transport in 1994 to that in 1995?
Keep it short and to the point. 1.05. What is the ratio of the CO2 emissions (% of total fuel combustion) in Other sectors in 1994 to that in 1996?
Your answer should be very brief. 0.82. What is the ratio of the CO2 emissions (% of total fuel combustion) in Resident buildings and public services in 1994 to that in 1996?
Make the answer very short. 0.89. What is the ratio of the CO2 emissions (% of total fuel combustion) of Transport in 1994 to that in 1996?
Your response must be concise. 1.03. What is the ratio of the CO2 emissions (% of total fuel combustion) in Other sectors in 1994 to that in 1997?
Your answer should be very brief. 0.81. What is the ratio of the CO2 emissions (% of total fuel combustion) of Resident buildings and public services in 1994 to that in 1997?
Your response must be concise. 0.87. What is the ratio of the CO2 emissions (% of total fuel combustion) in Transport in 1994 to that in 1997?
Offer a terse response. 1.08. What is the ratio of the CO2 emissions (% of total fuel combustion) in Other sectors in 1994 to that in 1998?
Your answer should be compact. 0.74. What is the ratio of the CO2 emissions (% of total fuel combustion) in Resident buildings and public services in 1994 to that in 1998?
Offer a very short reply. 0.89. What is the ratio of the CO2 emissions (% of total fuel combustion) in Transport in 1994 to that in 1998?
Give a very brief answer. 1.06. What is the ratio of the CO2 emissions (% of total fuel combustion) of Other sectors in 1994 to that in 1999?
Offer a very short reply. 0.63. What is the ratio of the CO2 emissions (% of total fuel combustion) in Resident buildings and public services in 1994 to that in 1999?
Ensure brevity in your answer.  0.93. What is the ratio of the CO2 emissions (% of total fuel combustion) of Transport in 1994 to that in 1999?
Your answer should be very brief. 1.12. What is the ratio of the CO2 emissions (% of total fuel combustion) in Other sectors in 1994 to that in 2000?
Make the answer very short. 0.81. What is the ratio of the CO2 emissions (% of total fuel combustion) in Resident buildings and public services in 1994 to that in 2000?
Make the answer very short. 0.96. What is the ratio of the CO2 emissions (% of total fuel combustion) of Transport in 1994 to that in 2000?
Keep it short and to the point. 1.12. What is the ratio of the CO2 emissions (% of total fuel combustion) of Other sectors in 1995 to that in 1996?
Your response must be concise. 1.03. What is the ratio of the CO2 emissions (% of total fuel combustion) of Resident buildings and public services in 1995 to that in 1996?
Provide a short and direct response. 0.89. What is the ratio of the CO2 emissions (% of total fuel combustion) of Transport in 1995 to that in 1996?
Provide a succinct answer. 0.99. What is the ratio of the CO2 emissions (% of total fuel combustion) of Other sectors in 1995 to that in 1997?
Keep it short and to the point. 1.03. What is the ratio of the CO2 emissions (% of total fuel combustion) in Resident buildings and public services in 1995 to that in 1997?
Offer a terse response. 0.87. What is the ratio of the CO2 emissions (% of total fuel combustion) of Transport in 1995 to that in 1997?
Provide a succinct answer. 1.03. What is the ratio of the CO2 emissions (% of total fuel combustion) in Other sectors in 1995 to that in 1998?
Make the answer very short. 0.93. What is the ratio of the CO2 emissions (% of total fuel combustion) in Resident buildings and public services in 1995 to that in 1998?
Keep it short and to the point. 0.89. What is the ratio of the CO2 emissions (% of total fuel combustion) of Transport in 1995 to that in 1998?
Offer a very short reply. 1.01. What is the ratio of the CO2 emissions (% of total fuel combustion) in Other sectors in 1995 to that in 1999?
Your response must be concise. 0.79. What is the ratio of the CO2 emissions (% of total fuel combustion) of Resident buildings and public services in 1995 to that in 1999?
Offer a terse response. 0.94. What is the ratio of the CO2 emissions (% of total fuel combustion) in Transport in 1995 to that in 1999?
Offer a very short reply. 1.07. What is the ratio of the CO2 emissions (% of total fuel combustion) in Other sectors in 1995 to that in 2000?
Make the answer very short. 1.02. What is the ratio of the CO2 emissions (% of total fuel combustion) of Resident buildings and public services in 1995 to that in 2000?
Give a very brief answer. 0.96. What is the ratio of the CO2 emissions (% of total fuel combustion) in Transport in 1995 to that in 2000?
Provide a short and direct response. 1.07. What is the ratio of the CO2 emissions (% of total fuel combustion) in Resident buildings and public services in 1996 to that in 1997?
Your response must be concise. 0.98. What is the ratio of the CO2 emissions (% of total fuel combustion) of Transport in 1996 to that in 1997?
Give a very brief answer. 1.04. What is the ratio of the CO2 emissions (% of total fuel combustion) of Other sectors in 1996 to that in 1998?
Your answer should be very brief. 0.9. What is the ratio of the CO2 emissions (% of total fuel combustion) in Transport in 1996 to that in 1998?
Make the answer very short. 1.03. What is the ratio of the CO2 emissions (% of total fuel combustion) of Other sectors in 1996 to that in 1999?
Your response must be concise. 0.77. What is the ratio of the CO2 emissions (% of total fuel combustion) of Resident buildings and public services in 1996 to that in 1999?
Provide a succinct answer. 1.05. What is the ratio of the CO2 emissions (% of total fuel combustion) of Transport in 1996 to that in 1999?
Your response must be concise. 1.09. What is the ratio of the CO2 emissions (% of total fuel combustion) of Other sectors in 1996 to that in 2000?
Your answer should be very brief. 0.99. What is the ratio of the CO2 emissions (% of total fuel combustion) of Resident buildings and public services in 1996 to that in 2000?
Give a very brief answer. 1.08. What is the ratio of the CO2 emissions (% of total fuel combustion) of Transport in 1996 to that in 2000?
Your answer should be compact. 1.09. What is the ratio of the CO2 emissions (% of total fuel combustion) of Other sectors in 1997 to that in 1998?
Your answer should be compact. 0.91. What is the ratio of the CO2 emissions (% of total fuel combustion) in Resident buildings and public services in 1997 to that in 1998?
Offer a very short reply. 1.02. What is the ratio of the CO2 emissions (% of total fuel combustion) in Transport in 1997 to that in 1998?
Your answer should be very brief. 0.98. What is the ratio of the CO2 emissions (% of total fuel combustion) in Other sectors in 1997 to that in 1999?
Offer a terse response. 0.77. What is the ratio of the CO2 emissions (% of total fuel combustion) of Resident buildings and public services in 1997 to that in 1999?
Keep it short and to the point. 1.07. What is the ratio of the CO2 emissions (% of total fuel combustion) in Transport in 1997 to that in 1999?
Make the answer very short. 1.04. What is the ratio of the CO2 emissions (% of total fuel combustion) of Resident buildings and public services in 1997 to that in 2000?
Give a very brief answer. 1.1. What is the ratio of the CO2 emissions (% of total fuel combustion) in Transport in 1997 to that in 2000?
Provide a short and direct response. 1.04. What is the ratio of the CO2 emissions (% of total fuel combustion) of Other sectors in 1998 to that in 1999?
Your response must be concise. 0.85. What is the ratio of the CO2 emissions (% of total fuel combustion) in Resident buildings and public services in 1998 to that in 1999?
Keep it short and to the point. 1.05. What is the ratio of the CO2 emissions (% of total fuel combustion) of Transport in 1998 to that in 1999?
Provide a short and direct response. 1.06. What is the ratio of the CO2 emissions (% of total fuel combustion) of Other sectors in 1998 to that in 2000?
Keep it short and to the point. 1.09. What is the ratio of the CO2 emissions (% of total fuel combustion) in Resident buildings and public services in 1998 to that in 2000?
Make the answer very short. 1.07. What is the ratio of the CO2 emissions (% of total fuel combustion) of Transport in 1998 to that in 2000?
Offer a very short reply. 1.06. What is the ratio of the CO2 emissions (% of total fuel combustion) in Other sectors in 1999 to that in 2000?
Keep it short and to the point. 1.28. What is the ratio of the CO2 emissions (% of total fuel combustion) in Resident buildings and public services in 1999 to that in 2000?
Provide a succinct answer. 1.02. What is the difference between the highest and the second highest CO2 emissions (% of total fuel combustion) in Other sectors?
Keep it short and to the point. 1.19. What is the difference between the highest and the second highest CO2 emissions (% of total fuel combustion) in Resident buildings and public services?
Offer a very short reply. 0.26. What is the difference between the highest and the second highest CO2 emissions (% of total fuel combustion) in Transport?
Offer a very short reply. 2.13. What is the difference between the highest and the lowest CO2 emissions (% of total fuel combustion) in Other sectors?
Provide a short and direct response. 2.99. What is the difference between the highest and the lowest CO2 emissions (% of total fuel combustion) of Resident buildings and public services?
Provide a succinct answer. 2.43. What is the difference between the highest and the lowest CO2 emissions (% of total fuel combustion) of Transport?
Provide a succinct answer. 5.98. 